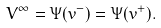<formula> <loc_0><loc_0><loc_500><loc_500>V ^ { \infty } = \Psi ( v ^ { - } ) = \Psi ( v ^ { + } ) .</formula> 